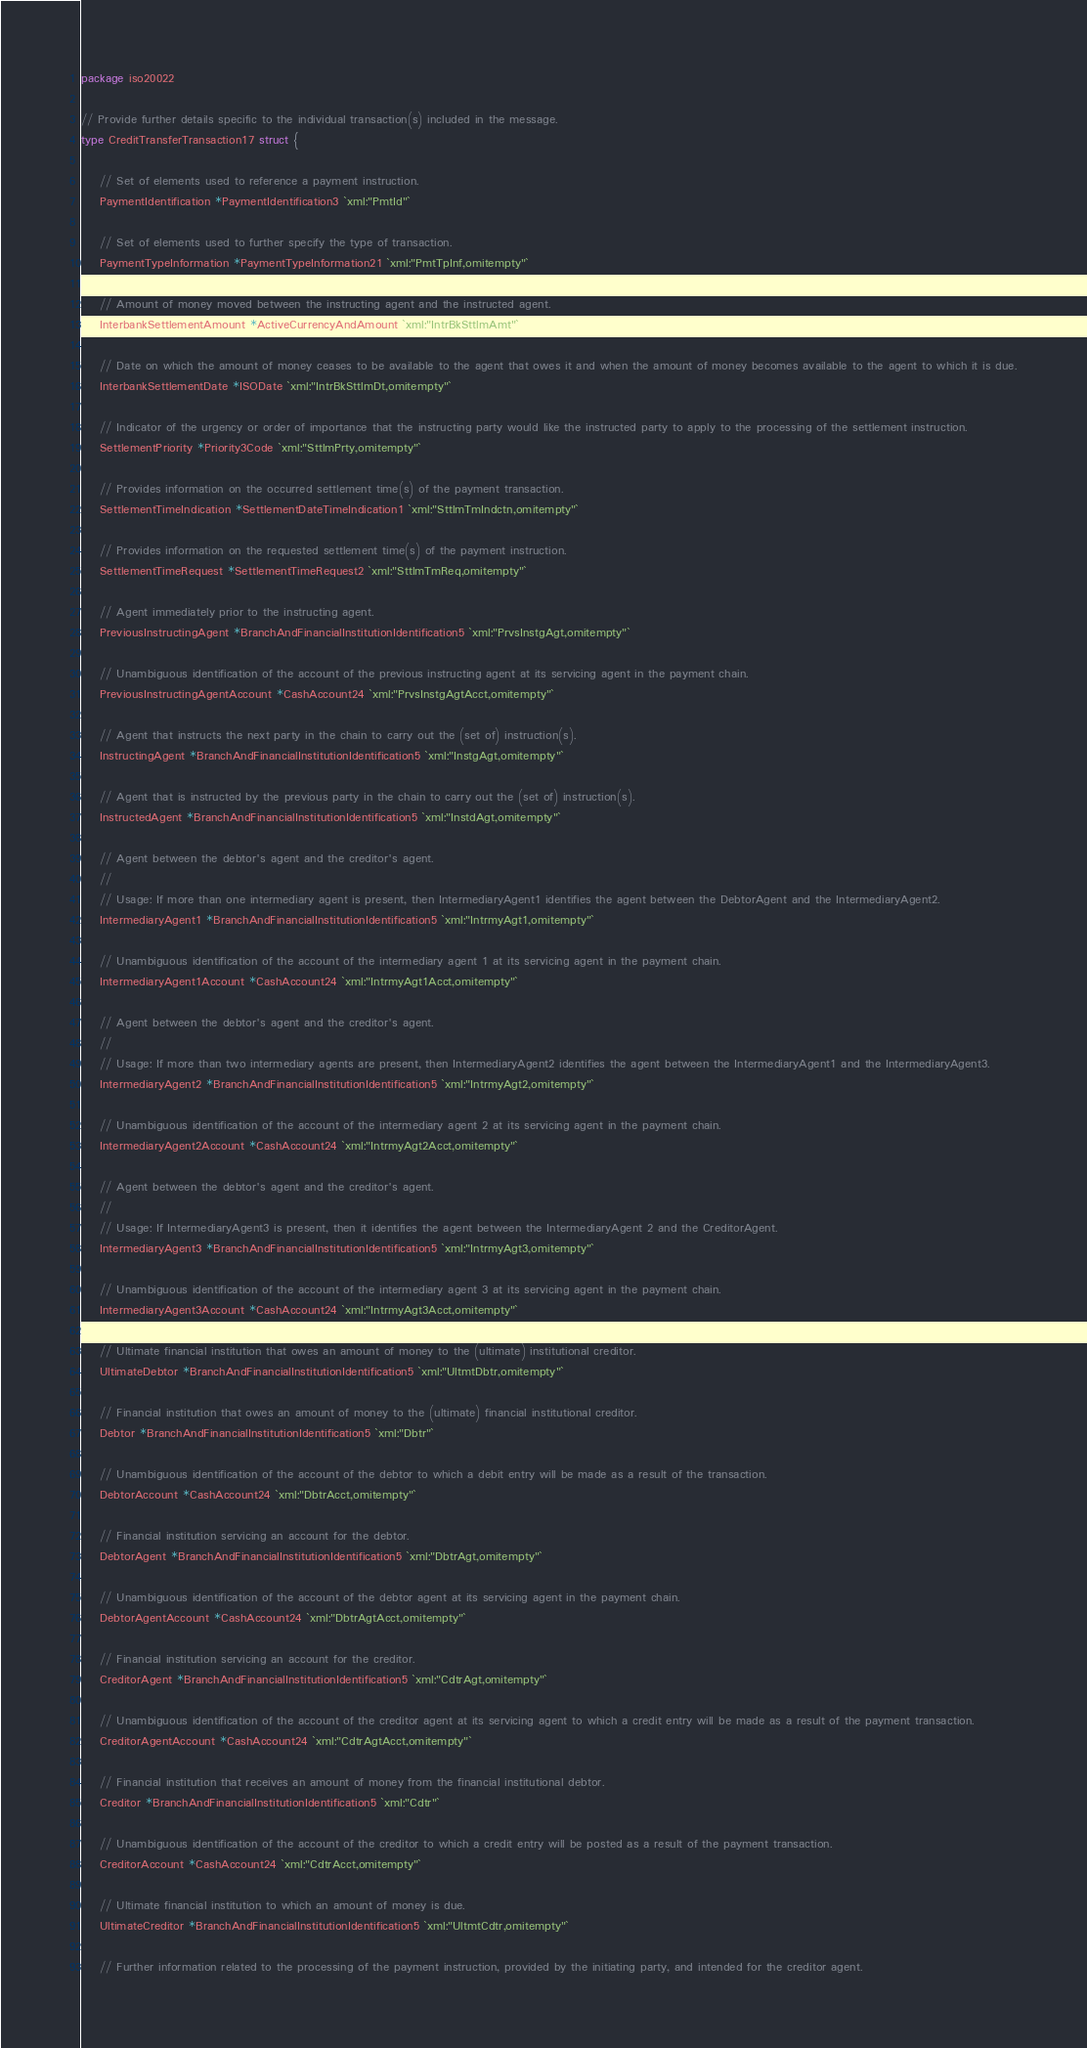Convert code to text. <code><loc_0><loc_0><loc_500><loc_500><_Go_>package iso20022

// Provide further details specific to the individual transaction(s) included in the message.
type CreditTransferTransaction17 struct {

	// Set of elements used to reference a payment instruction.
	PaymentIdentification *PaymentIdentification3 `xml:"PmtId"`

	// Set of elements used to further specify the type of transaction.
	PaymentTypeInformation *PaymentTypeInformation21 `xml:"PmtTpInf,omitempty"`

	// Amount of money moved between the instructing agent and the instructed agent.
	InterbankSettlementAmount *ActiveCurrencyAndAmount `xml:"IntrBkSttlmAmt"`

	// Date on which the amount of money ceases to be available to the agent that owes it and when the amount of money becomes available to the agent to which it is due.
	InterbankSettlementDate *ISODate `xml:"IntrBkSttlmDt,omitempty"`

	// Indicator of the urgency or order of importance that the instructing party would like the instructed party to apply to the processing of the settlement instruction.
	SettlementPriority *Priority3Code `xml:"SttlmPrty,omitempty"`

	// Provides information on the occurred settlement time(s) of the payment transaction.
	SettlementTimeIndication *SettlementDateTimeIndication1 `xml:"SttlmTmIndctn,omitempty"`

	// Provides information on the requested settlement time(s) of the payment instruction.
	SettlementTimeRequest *SettlementTimeRequest2 `xml:"SttlmTmReq,omitempty"`

	// Agent immediately prior to the instructing agent.
	PreviousInstructingAgent *BranchAndFinancialInstitutionIdentification5 `xml:"PrvsInstgAgt,omitempty"`

	// Unambiguous identification of the account of the previous instructing agent at its servicing agent in the payment chain.
	PreviousInstructingAgentAccount *CashAccount24 `xml:"PrvsInstgAgtAcct,omitempty"`

	// Agent that instructs the next party in the chain to carry out the (set of) instruction(s).
	InstructingAgent *BranchAndFinancialInstitutionIdentification5 `xml:"InstgAgt,omitempty"`

	// Agent that is instructed by the previous party in the chain to carry out the (set of) instruction(s).
	InstructedAgent *BranchAndFinancialInstitutionIdentification5 `xml:"InstdAgt,omitempty"`

	// Agent between the debtor's agent and the creditor's agent.
	//
	// Usage: If more than one intermediary agent is present, then IntermediaryAgent1 identifies the agent between the DebtorAgent and the IntermediaryAgent2.
	IntermediaryAgent1 *BranchAndFinancialInstitutionIdentification5 `xml:"IntrmyAgt1,omitempty"`

	// Unambiguous identification of the account of the intermediary agent 1 at its servicing agent in the payment chain.
	IntermediaryAgent1Account *CashAccount24 `xml:"IntrmyAgt1Acct,omitempty"`

	// Agent between the debtor's agent and the creditor's agent.
	//
	// Usage: If more than two intermediary agents are present, then IntermediaryAgent2 identifies the agent between the IntermediaryAgent1 and the IntermediaryAgent3.
	IntermediaryAgent2 *BranchAndFinancialInstitutionIdentification5 `xml:"IntrmyAgt2,omitempty"`

	// Unambiguous identification of the account of the intermediary agent 2 at its servicing agent in the payment chain.
	IntermediaryAgent2Account *CashAccount24 `xml:"IntrmyAgt2Acct,omitempty"`

	// Agent between the debtor's agent and the creditor's agent.
	//
	// Usage: If IntermediaryAgent3 is present, then it identifies the agent between the IntermediaryAgent 2 and the CreditorAgent.
	IntermediaryAgent3 *BranchAndFinancialInstitutionIdentification5 `xml:"IntrmyAgt3,omitempty"`

	// Unambiguous identification of the account of the intermediary agent 3 at its servicing agent in the payment chain.
	IntermediaryAgent3Account *CashAccount24 `xml:"IntrmyAgt3Acct,omitempty"`

	// Ultimate financial institution that owes an amount of money to the (ultimate) institutional creditor.
	UltimateDebtor *BranchAndFinancialInstitutionIdentification5 `xml:"UltmtDbtr,omitempty"`

	// Financial institution that owes an amount of money to the (ultimate) financial institutional creditor.
	Debtor *BranchAndFinancialInstitutionIdentification5 `xml:"Dbtr"`

	// Unambiguous identification of the account of the debtor to which a debit entry will be made as a result of the transaction.
	DebtorAccount *CashAccount24 `xml:"DbtrAcct,omitempty"`

	// Financial institution servicing an account for the debtor.
	DebtorAgent *BranchAndFinancialInstitutionIdentification5 `xml:"DbtrAgt,omitempty"`

	// Unambiguous identification of the account of the debtor agent at its servicing agent in the payment chain.
	DebtorAgentAccount *CashAccount24 `xml:"DbtrAgtAcct,omitempty"`

	// Financial institution servicing an account for the creditor.
	CreditorAgent *BranchAndFinancialInstitutionIdentification5 `xml:"CdtrAgt,omitempty"`

	// Unambiguous identification of the account of the creditor agent at its servicing agent to which a credit entry will be made as a result of the payment transaction.
	CreditorAgentAccount *CashAccount24 `xml:"CdtrAgtAcct,omitempty"`

	// Financial institution that receives an amount of money from the financial institutional debtor.
	Creditor *BranchAndFinancialInstitutionIdentification5 `xml:"Cdtr"`

	// Unambiguous identification of the account of the creditor to which a credit entry will be posted as a result of the payment transaction.
	CreditorAccount *CashAccount24 `xml:"CdtrAcct,omitempty"`

	// Ultimate financial institution to which an amount of money is due.
	UltimateCreditor *BranchAndFinancialInstitutionIdentification5 `xml:"UltmtCdtr,omitempty"`

	// Further information related to the processing of the payment instruction, provided by the initiating party, and intended for the creditor agent.</code> 